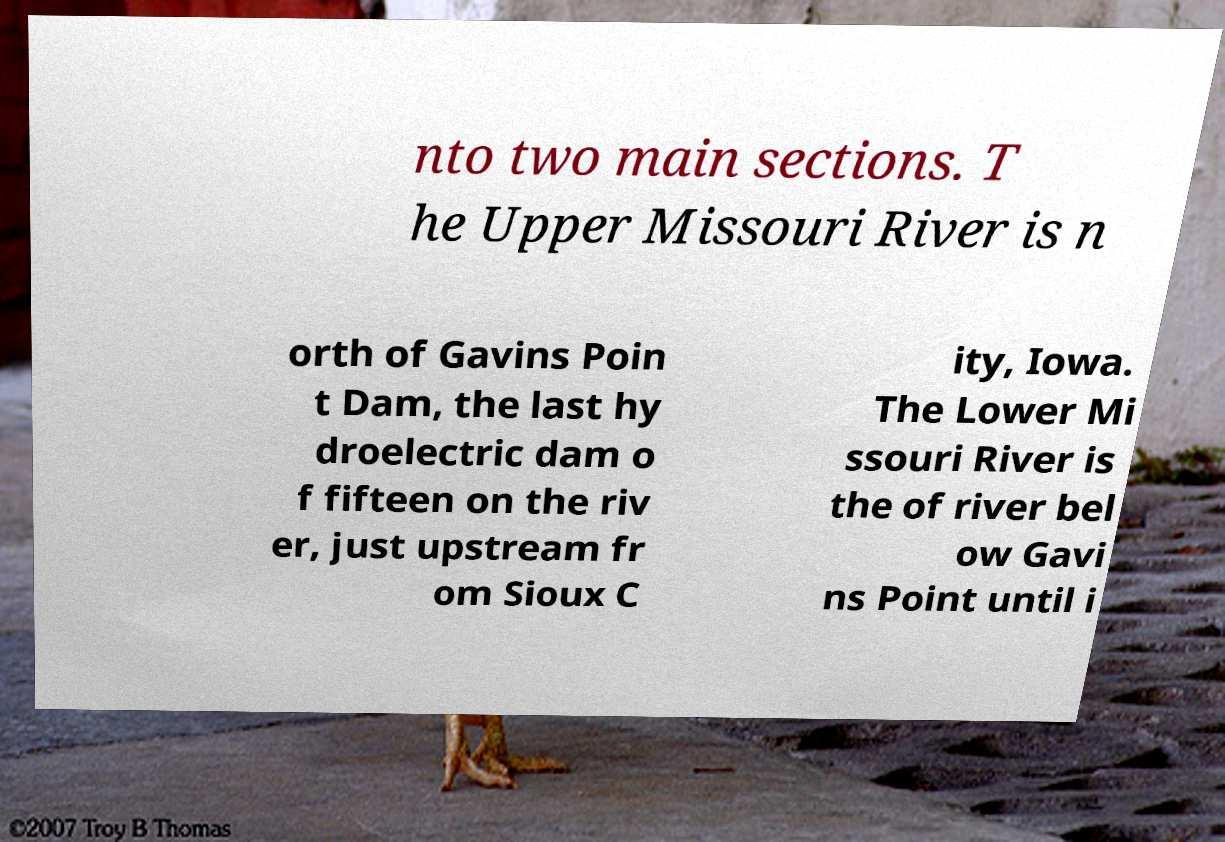For documentation purposes, I need the text within this image transcribed. Could you provide that? nto two main sections. T he Upper Missouri River is n orth of Gavins Poin t Dam, the last hy droelectric dam o f fifteen on the riv er, just upstream fr om Sioux C ity, Iowa. The Lower Mi ssouri River is the of river bel ow Gavi ns Point until i 